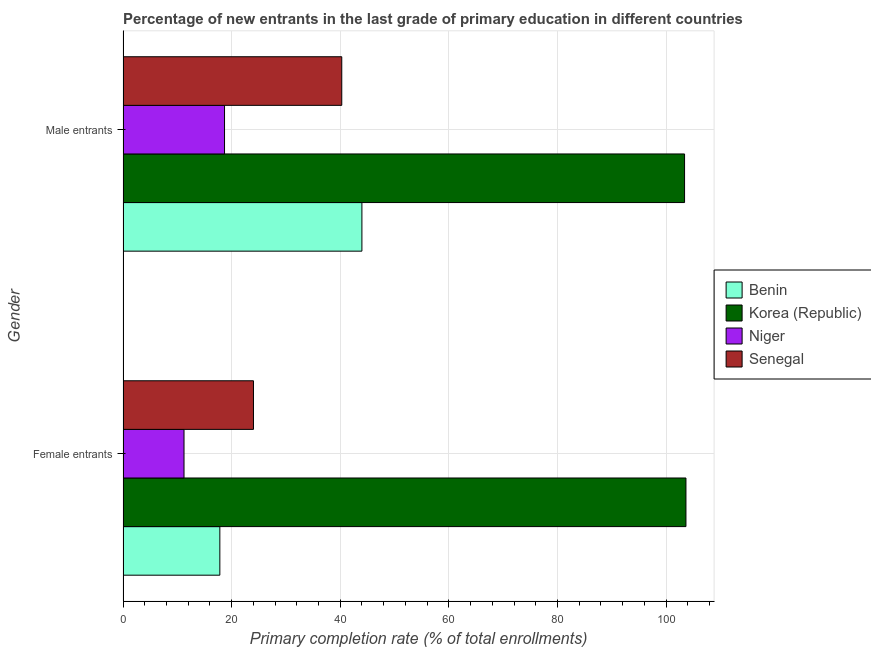How many groups of bars are there?
Your answer should be very brief. 2. What is the label of the 1st group of bars from the top?
Give a very brief answer. Male entrants. What is the primary completion rate of female entrants in Niger?
Your answer should be compact. 11.24. Across all countries, what is the maximum primary completion rate of female entrants?
Offer a very short reply. 103.66. Across all countries, what is the minimum primary completion rate of male entrants?
Offer a terse response. 18.7. In which country was the primary completion rate of male entrants maximum?
Offer a very short reply. Korea (Republic). In which country was the primary completion rate of male entrants minimum?
Provide a short and direct response. Niger. What is the total primary completion rate of male entrants in the graph?
Keep it short and to the point. 206.38. What is the difference between the primary completion rate of female entrants in Korea (Republic) and that in Niger?
Offer a very short reply. 92.43. What is the difference between the primary completion rate of female entrants in Korea (Republic) and the primary completion rate of male entrants in Niger?
Provide a short and direct response. 84.97. What is the average primary completion rate of female entrants per country?
Provide a succinct answer. 39.19. What is the difference between the primary completion rate of male entrants and primary completion rate of female entrants in Niger?
Give a very brief answer. 7.46. In how many countries, is the primary completion rate of male entrants greater than 24 %?
Make the answer very short. 3. What is the ratio of the primary completion rate of female entrants in Korea (Republic) to that in Benin?
Offer a very short reply. 5.81. Is the primary completion rate of female entrants in Benin less than that in Senegal?
Provide a short and direct response. Yes. What does the 1st bar from the top in Male entrants represents?
Make the answer very short. Senegal. What does the 1st bar from the bottom in Female entrants represents?
Provide a succinct answer. Benin. How many bars are there?
Provide a short and direct response. 8. Are the values on the major ticks of X-axis written in scientific E-notation?
Offer a very short reply. No. Does the graph contain grids?
Keep it short and to the point. Yes. Where does the legend appear in the graph?
Give a very brief answer. Center right. How many legend labels are there?
Give a very brief answer. 4. What is the title of the graph?
Ensure brevity in your answer.  Percentage of new entrants in the last grade of primary education in different countries. What is the label or title of the X-axis?
Offer a very short reply. Primary completion rate (% of total enrollments). What is the label or title of the Y-axis?
Your answer should be very brief. Gender. What is the Primary completion rate (% of total enrollments) of Benin in Female entrants?
Give a very brief answer. 17.83. What is the Primary completion rate (% of total enrollments) of Korea (Republic) in Female entrants?
Offer a very short reply. 103.66. What is the Primary completion rate (% of total enrollments) of Niger in Female entrants?
Your answer should be compact. 11.24. What is the Primary completion rate (% of total enrollments) in Senegal in Female entrants?
Offer a very short reply. 24.03. What is the Primary completion rate (% of total enrollments) of Benin in Male entrants?
Your answer should be very brief. 43.99. What is the Primary completion rate (% of total enrollments) in Korea (Republic) in Male entrants?
Offer a very short reply. 103.41. What is the Primary completion rate (% of total enrollments) of Niger in Male entrants?
Offer a terse response. 18.7. What is the Primary completion rate (% of total enrollments) of Senegal in Male entrants?
Your response must be concise. 40.29. Across all Gender, what is the maximum Primary completion rate (% of total enrollments) in Benin?
Provide a short and direct response. 43.99. Across all Gender, what is the maximum Primary completion rate (% of total enrollments) in Korea (Republic)?
Your answer should be compact. 103.66. Across all Gender, what is the maximum Primary completion rate (% of total enrollments) of Niger?
Give a very brief answer. 18.7. Across all Gender, what is the maximum Primary completion rate (% of total enrollments) of Senegal?
Ensure brevity in your answer.  40.29. Across all Gender, what is the minimum Primary completion rate (% of total enrollments) of Benin?
Ensure brevity in your answer.  17.83. Across all Gender, what is the minimum Primary completion rate (% of total enrollments) of Korea (Republic)?
Make the answer very short. 103.41. Across all Gender, what is the minimum Primary completion rate (% of total enrollments) in Niger?
Offer a very short reply. 11.24. Across all Gender, what is the minimum Primary completion rate (% of total enrollments) in Senegal?
Offer a very short reply. 24.03. What is the total Primary completion rate (% of total enrollments) of Benin in the graph?
Ensure brevity in your answer.  61.83. What is the total Primary completion rate (% of total enrollments) in Korea (Republic) in the graph?
Offer a very short reply. 207.07. What is the total Primary completion rate (% of total enrollments) of Niger in the graph?
Keep it short and to the point. 29.93. What is the total Primary completion rate (% of total enrollments) in Senegal in the graph?
Your response must be concise. 64.31. What is the difference between the Primary completion rate (% of total enrollments) of Benin in Female entrants and that in Male entrants?
Provide a short and direct response. -26.16. What is the difference between the Primary completion rate (% of total enrollments) of Korea (Republic) in Female entrants and that in Male entrants?
Your answer should be very brief. 0.26. What is the difference between the Primary completion rate (% of total enrollments) of Niger in Female entrants and that in Male entrants?
Make the answer very short. -7.46. What is the difference between the Primary completion rate (% of total enrollments) of Senegal in Female entrants and that in Male entrants?
Make the answer very short. -16.26. What is the difference between the Primary completion rate (% of total enrollments) of Benin in Female entrants and the Primary completion rate (% of total enrollments) of Korea (Republic) in Male entrants?
Make the answer very short. -85.57. What is the difference between the Primary completion rate (% of total enrollments) in Benin in Female entrants and the Primary completion rate (% of total enrollments) in Niger in Male entrants?
Your answer should be compact. -0.86. What is the difference between the Primary completion rate (% of total enrollments) in Benin in Female entrants and the Primary completion rate (% of total enrollments) in Senegal in Male entrants?
Make the answer very short. -22.45. What is the difference between the Primary completion rate (% of total enrollments) in Korea (Republic) in Female entrants and the Primary completion rate (% of total enrollments) in Niger in Male entrants?
Provide a short and direct response. 84.97. What is the difference between the Primary completion rate (% of total enrollments) of Korea (Republic) in Female entrants and the Primary completion rate (% of total enrollments) of Senegal in Male entrants?
Your answer should be compact. 63.38. What is the difference between the Primary completion rate (% of total enrollments) of Niger in Female entrants and the Primary completion rate (% of total enrollments) of Senegal in Male entrants?
Offer a very short reply. -29.05. What is the average Primary completion rate (% of total enrollments) of Benin per Gender?
Provide a short and direct response. 30.91. What is the average Primary completion rate (% of total enrollments) in Korea (Republic) per Gender?
Your answer should be compact. 103.54. What is the average Primary completion rate (% of total enrollments) of Niger per Gender?
Your answer should be compact. 14.97. What is the average Primary completion rate (% of total enrollments) in Senegal per Gender?
Ensure brevity in your answer.  32.16. What is the difference between the Primary completion rate (% of total enrollments) in Benin and Primary completion rate (% of total enrollments) in Korea (Republic) in Female entrants?
Give a very brief answer. -85.83. What is the difference between the Primary completion rate (% of total enrollments) in Benin and Primary completion rate (% of total enrollments) in Niger in Female entrants?
Offer a very short reply. 6.6. What is the difference between the Primary completion rate (% of total enrollments) in Benin and Primary completion rate (% of total enrollments) in Senegal in Female entrants?
Keep it short and to the point. -6.19. What is the difference between the Primary completion rate (% of total enrollments) of Korea (Republic) and Primary completion rate (% of total enrollments) of Niger in Female entrants?
Your response must be concise. 92.43. What is the difference between the Primary completion rate (% of total enrollments) of Korea (Republic) and Primary completion rate (% of total enrollments) of Senegal in Female entrants?
Your response must be concise. 79.64. What is the difference between the Primary completion rate (% of total enrollments) of Niger and Primary completion rate (% of total enrollments) of Senegal in Female entrants?
Your answer should be compact. -12.79. What is the difference between the Primary completion rate (% of total enrollments) in Benin and Primary completion rate (% of total enrollments) in Korea (Republic) in Male entrants?
Keep it short and to the point. -59.41. What is the difference between the Primary completion rate (% of total enrollments) in Benin and Primary completion rate (% of total enrollments) in Niger in Male entrants?
Offer a very short reply. 25.3. What is the difference between the Primary completion rate (% of total enrollments) of Benin and Primary completion rate (% of total enrollments) of Senegal in Male entrants?
Offer a very short reply. 3.71. What is the difference between the Primary completion rate (% of total enrollments) in Korea (Republic) and Primary completion rate (% of total enrollments) in Niger in Male entrants?
Your answer should be compact. 84.71. What is the difference between the Primary completion rate (% of total enrollments) in Korea (Republic) and Primary completion rate (% of total enrollments) in Senegal in Male entrants?
Provide a succinct answer. 63.12. What is the difference between the Primary completion rate (% of total enrollments) of Niger and Primary completion rate (% of total enrollments) of Senegal in Male entrants?
Ensure brevity in your answer.  -21.59. What is the ratio of the Primary completion rate (% of total enrollments) of Benin in Female entrants to that in Male entrants?
Keep it short and to the point. 0.41. What is the ratio of the Primary completion rate (% of total enrollments) in Korea (Republic) in Female entrants to that in Male entrants?
Provide a succinct answer. 1. What is the ratio of the Primary completion rate (% of total enrollments) of Niger in Female entrants to that in Male entrants?
Offer a very short reply. 0.6. What is the ratio of the Primary completion rate (% of total enrollments) of Senegal in Female entrants to that in Male entrants?
Offer a terse response. 0.6. What is the difference between the highest and the second highest Primary completion rate (% of total enrollments) of Benin?
Make the answer very short. 26.16. What is the difference between the highest and the second highest Primary completion rate (% of total enrollments) in Korea (Republic)?
Your answer should be compact. 0.26. What is the difference between the highest and the second highest Primary completion rate (% of total enrollments) of Niger?
Ensure brevity in your answer.  7.46. What is the difference between the highest and the second highest Primary completion rate (% of total enrollments) of Senegal?
Offer a very short reply. 16.26. What is the difference between the highest and the lowest Primary completion rate (% of total enrollments) in Benin?
Give a very brief answer. 26.16. What is the difference between the highest and the lowest Primary completion rate (% of total enrollments) of Korea (Republic)?
Your response must be concise. 0.26. What is the difference between the highest and the lowest Primary completion rate (% of total enrollments) in Niger?
Your answer should be compact. 7.46. What is the difference between the highest and the lowest Primary completion rate (% of total enrollments) in Senegal?
Give a very brief answer. 16.26. 